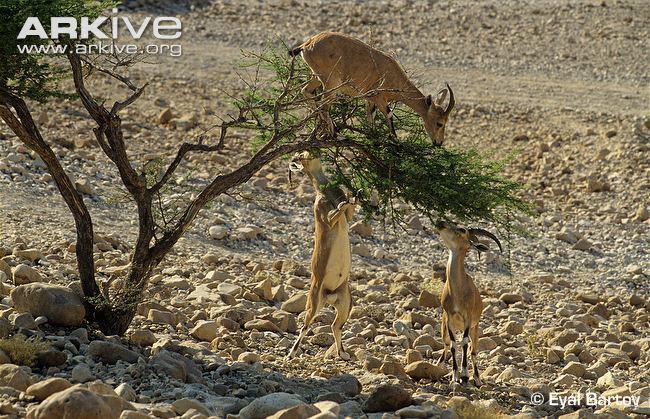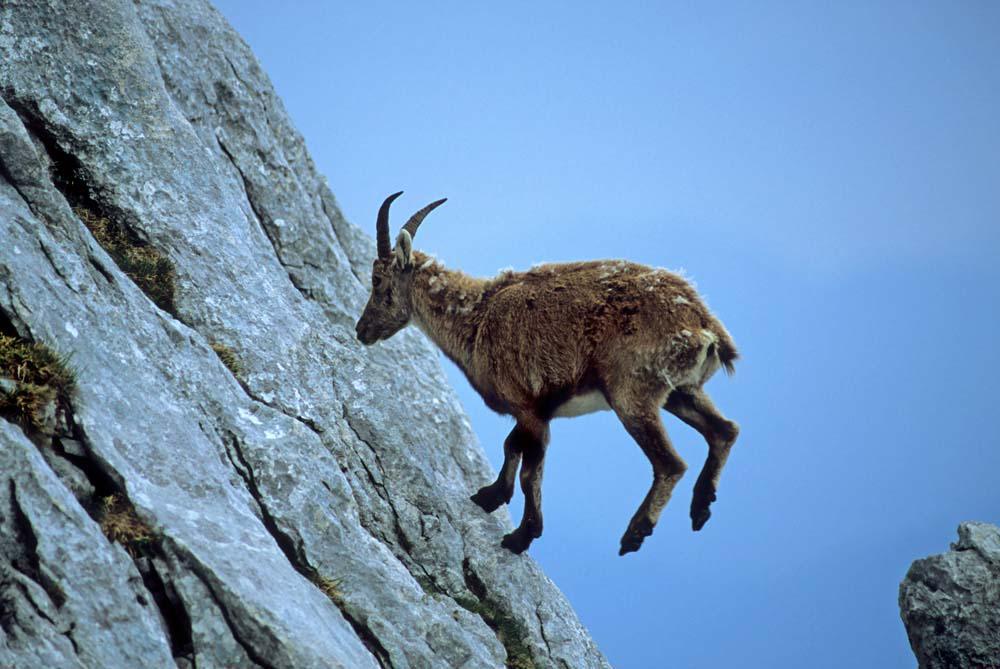The first image is the image on the left, the second image is the image on the right. Evaluate the accuracy of this statement regarding the images: "An ibex has its front paws off the ground.". Is it true? Answer yes or no. Yes. 